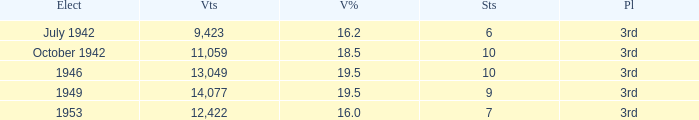Name the most vote % with election of 1946 19.5. 